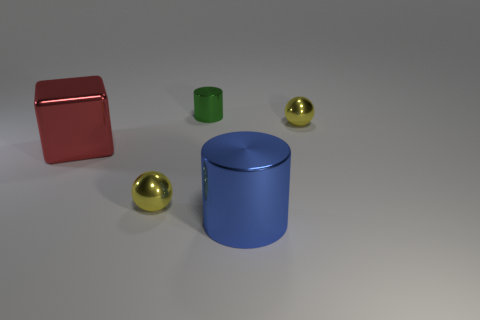Add 5 blue objects. How many objects exist? 10 Subtract 1 cylinders. How many cylinders are left? 1 Subtract all blue cylinders. How many cylinders are left? 1 Subtract all cylinders. How many objects are left? 3 Subtract 1 yellow balls. How many objects are left? 4 Subtract all blue balls. Subtract all yellow blocks. How many balls are left? 2 Subtract all green cubes. How many blue cylinders are left? 1 Subtract all blue metal cylinders. Subtract all red blocks. How many objects are left? 3 Add 4 small spheres. How many small spheres are left? 6 Add 4 cyan metallic things. How many cyan metallic things exist? 4 